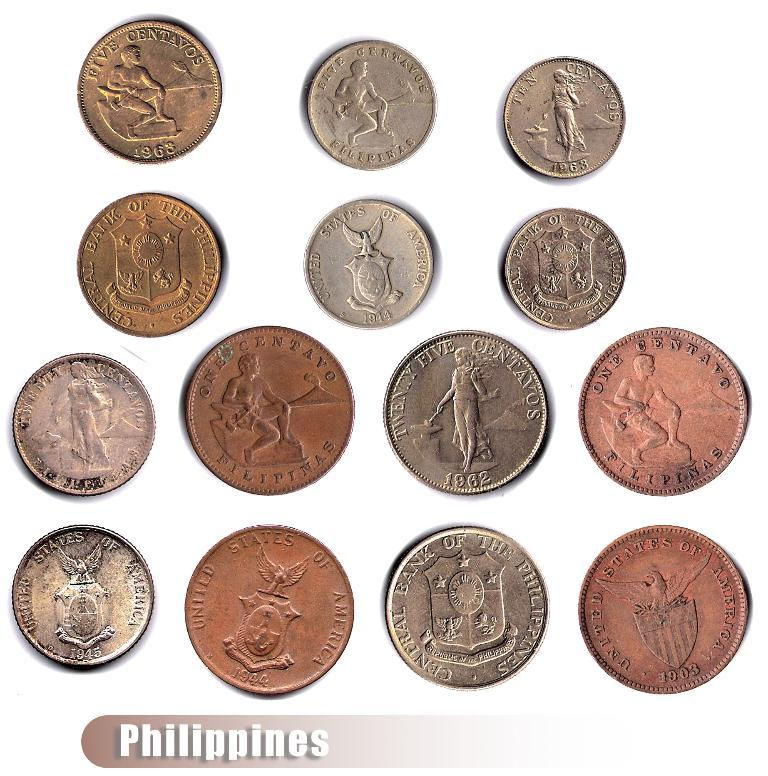<image>
Offer a succinct explanation of the picture presented. Bunch of philippines coins side by side including brown and silver coins 